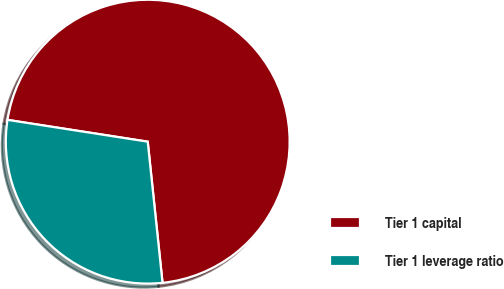Convert chart to OTSL. <chart><loc_0><loc_0><loc_500><loc_500><pie_chart><fcel>Tier 1 capital<fcel>Tier 1 leverage ratio<nl><fcel>70.88%<fcel>29.12%<nl></chart> 